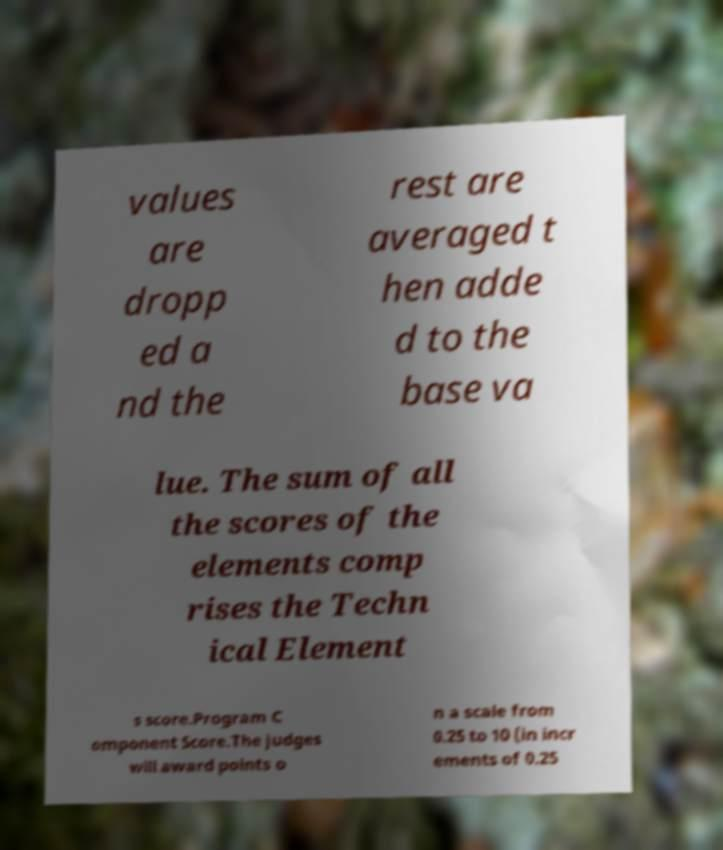Please identify and transcribe the text found in this image. values are dropp ed a nd the rest are averaged t hen adde d to the base va lue. The sum of all the scores of the elements comp rises the Techn ical Element s score.Program C omponent Score.The judges will award points o n a scale from 0.25 to 10 (in incr ements of 0.25 